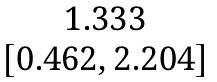<formula> <loc_0><loc_0><loc_500><loc_500>\begin{matrix} 1 . 3 3 3 \\ [ 0 . 4 6 2 , 2 . 2 0 4 ] \end{matrix}</formula> 